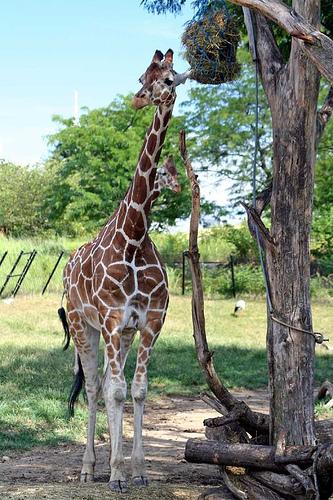How tall is this giraffe?
Keep it brief. Very. Are the giraffes looking at the camera?
Write a very short answer. No. What possible seasons is it outside?
Short answer required. Summer. What is the green ball above the giraffe?
Keep it brief. Food. What is inside the bundle hanging from the tree?
Concise answer only. Food. What is wrapped around the tree trunk?
Write a very short answer. Vine. 